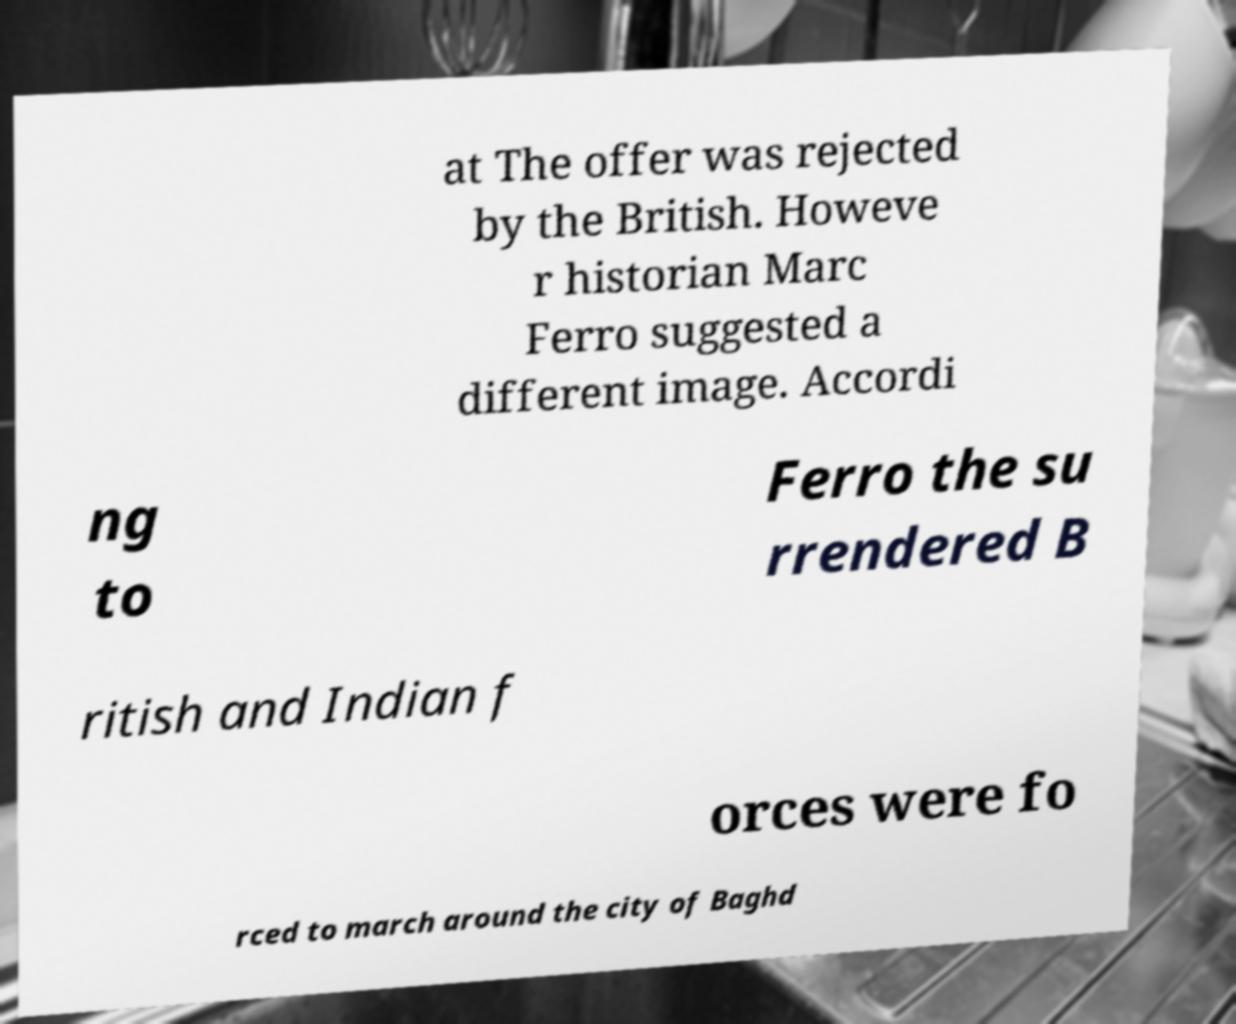There's text embedded in this image that I need extracted. Can you transcribe it verbatim? at The offer was rejected by the British. Howeve r historian Marc Ferro suggested a different image. Accordi ng to Ferro the su rrendered B ritish and Indian f orces were fo rced to march around the city of Baghd 